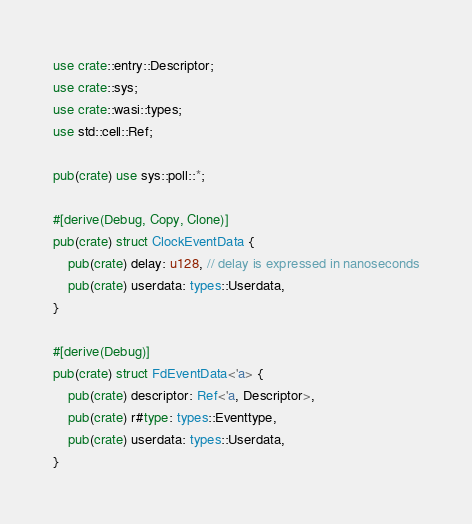Convert code to text. <code><loc_0><loc_0><loc_500><loc_500><_Rust_>use crate::entry::Descriptor;
use crate::sys;
use crate::wasi::types;
use std::cell::Ref;

pub(crate) use sys::poll::*;

#[derive(Debug, Copy, Clone)]
pub(crate) struct ClockEventData {
    pub(crate) delay: u128, // delay is expressed in nanoseconds
    pub(crate) userdata: types::Userdata,
}

#[derive(Debug)]
pub(crate) struct FdEventData<'a> {
    pub(crate) descriptor: Ref<'a, Descriptor>,
    pub(crate) r#type: types::Eventtype,
    pub(crate) userdata: types::Userdata,
}
</code> 